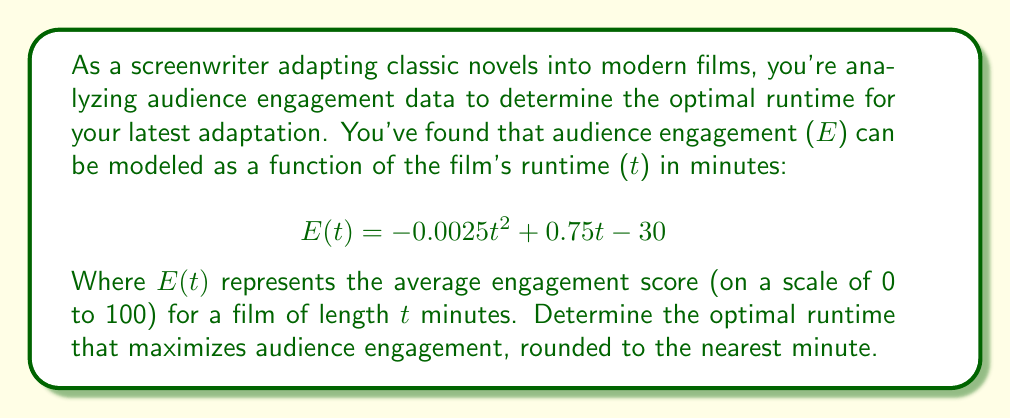Help me with this question. To find the optimal runtime that maximizes audience engagement, we need to find the maximum point of the quadratic function $E(t)$. Let's approach this step-by-step:

1) The function $E(t) = -0.0025t^2 + 0.75t - 30$ is a quadratic function in the form $f(x) = ax^2 + bx + c$, where:
   $a = -0.0025$
   $b = 0.75$
   $c = -30$

2) For a quadratic function, the x-coordinate of the vertex represents the point where the function reaches its maximum (if $a < 0$) or minimum (if $a > 0$). In this case, $a < 0$, so we're looking for the maximum.

3) The formula for the x-coordinate of the vertex is:
   $$t = -\frac{b}{2a}$$

4) Substituting our values:
   $$t = -\frac{0.75}{2(-0.0025)} = \frac{0.75}{0.005} = 150$$

5) Therefore, the engagement is maximized when $t = 150$ minutes.

6) To verify, we can calculate $E(149)$, $E(150)$, and $E(151)$:

   $E(149) = -0.0025(149)^2 + 0.75(149) - 30 = 26.2475$
   $E(150) = -0.0025(150)^2 + 0.75(150) - 30 = 26.25$
   $E(151) = -0.0025(151)^2 + 0.75(151) - 30 = 26.2475$

   This confirms that 150 minutes yields the highest engagement score.

7) Rounding to the nearest minute isn't necessary in this case, as 150 is already a whole number.
Answer: The optimal runtime that maximizes audience engagement is 150 minutes. 